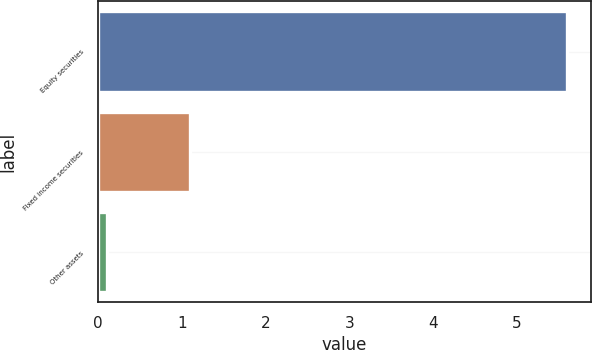Convert chart to OTSL. <chart><loc_0><loc_0><loc_500><loc_500><bar_chart><fcel>Equity securities<fcel>Fixed income securities<fcel>Other assets<nl><fcel>5.6<fcel>1.1<fcel>0.1<nl></chart> 